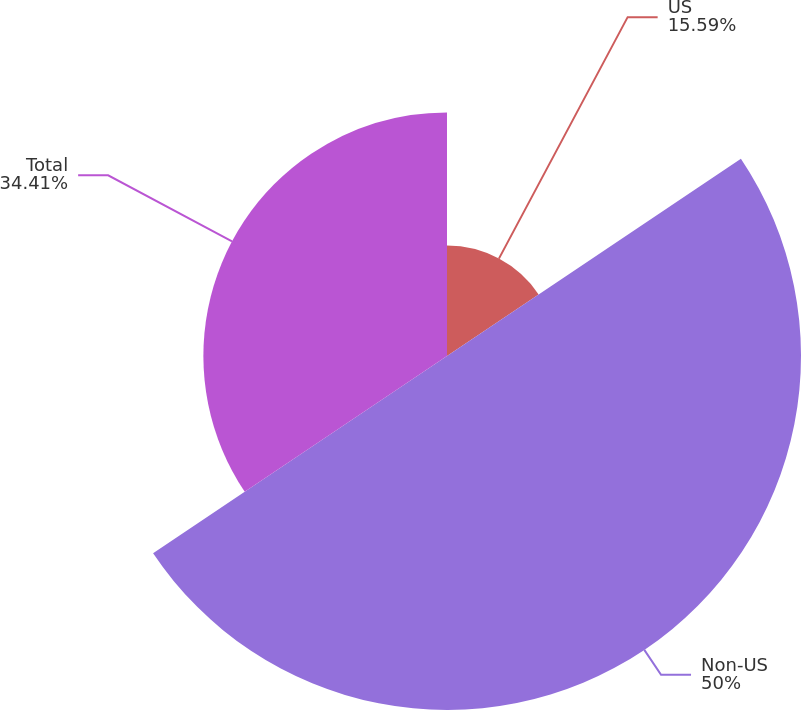<chart> <loc_0><loc_0><loc_500><loc_500><pie_chart><fcel>US<fcel>Non-US<fcel>Total<nl><fcel>15.59%<fcel>50.0%<fcel>34.41%<nl></chart> 